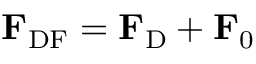<formula> <loc_0><loc_0><loc_500><loc_500>F _ { D F } = F _ { D } + F _ { 0 }</formula> 